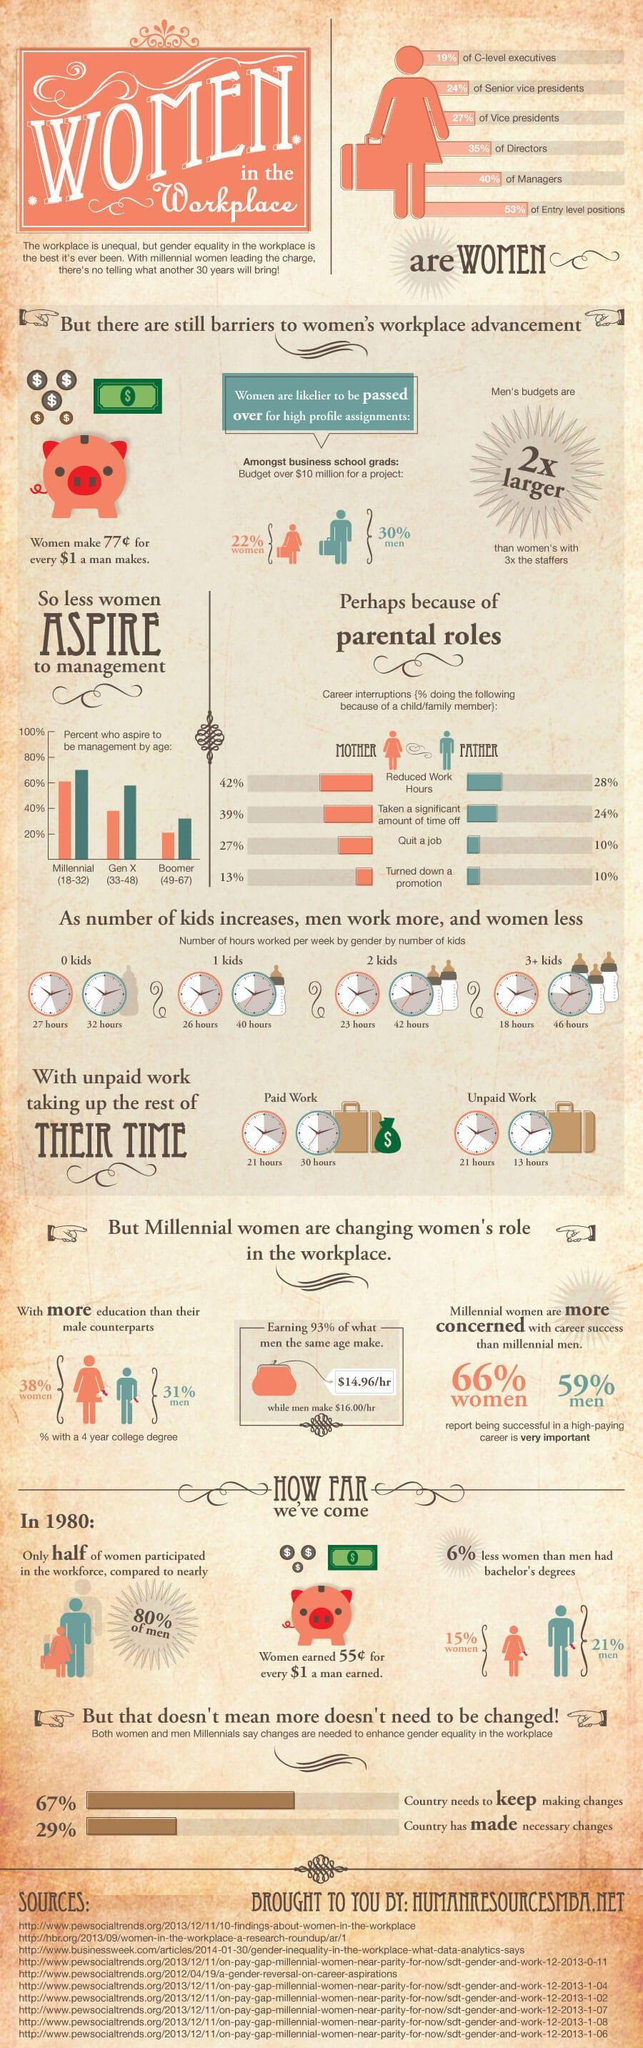What percentage of men were graduates in the year 1980?
Answer the question with a short phrase. 21% How hard do men work with a single kid? 40 hours How many countries are supporting women's empowerment? 29% How hard do women work with more than three kids? 18 hours What percentage of countries have not yet supported women's empowerment? 71 What percentage of men are college graduates? 31% What is the inverse percentage of women employees in top-level management? 81 What percentage of millennial women have achieved great success in their careers? 66% What is the second largest job title acquired by women? Managers What percentage of millennial men wants to become management? 70 